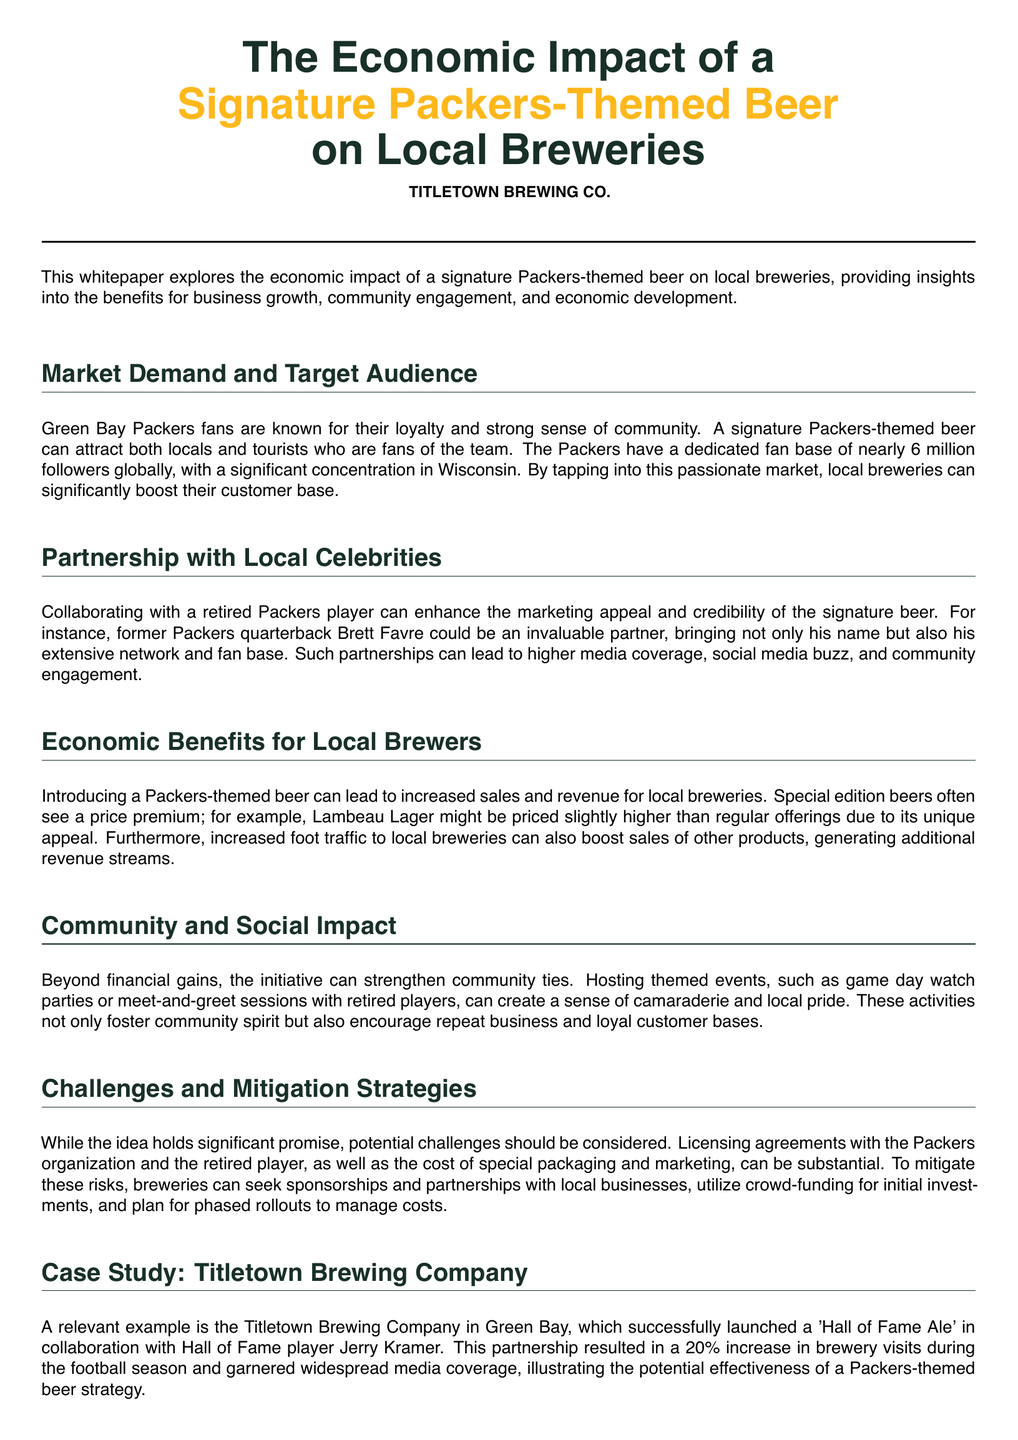What is the title of the whitepaper? The title is the primary focus of the document, summarizing the main theme regarding economic impact.
Answer: The Economic Impact of a Signature Packers-Themed Beer on Local Breweries Who could be a potential celebrity partner mentioned? The document discusses potential partnerships, specifically naming a retired Packers player who could enhance marketing.
Answer: Brett Favre What was the increase in brewery visits reported by Titletown Brewing Company? This figure demonstrates the success of the case study mentioned in the document, indicating potential effectiveness.
Answer: 20% What is one of the key audience demographics for the signature beer? The document identifies a specific group of people likely to be interested in the beer based on their allegiance to the Packers.
Answer: Packers fans What are two potential challenges mentioned? The whitepaper outlines challenges that breweries may face when introducing a Packers-themed beer, including logistical and financial aspects.
Answer: Licensing agreements, marketing costs What type of events can breweries host to strengthen community ties? The document suggests specific activities that can foster local pride and engagement through community events.
Answer: Game day watch parties What was the name of the beer launched by Titletown Brewing Company? This is a specific reference from the case study, showing a practical example of the concept discussed.
Answer: Hall of Fame Ale How can breweries mitigate the risks involved? The whitepaper lists strategies that breweries can adopt to address potential challenges when launching the themed beer.
Answer: Sponsorships and partnerships What is the main color theme used in the document? The color choices in the document are symbolic and relate to the subject, enhancing visual appeal.
Answer: Packer green and gold 